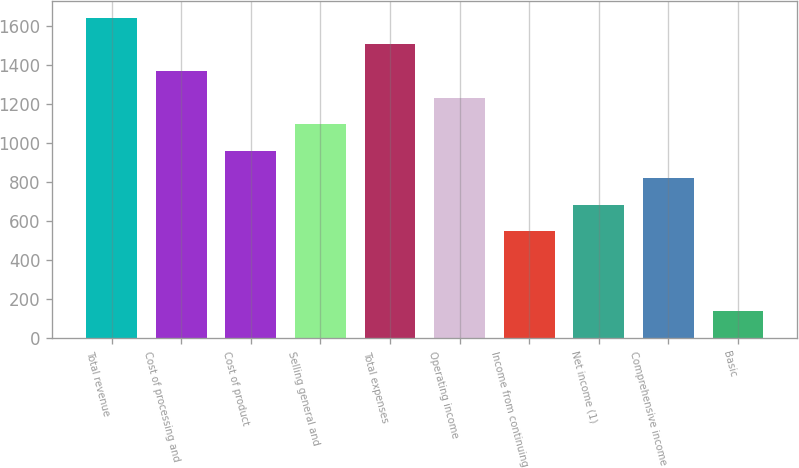Convert chart. <chart><loc_0><loc_0><loc_500><loc_500><bar_chart><fcel>Total revenue<fcel>Cost of processing and<fcel>Cost of product<fcel>Selling general and<fcel>Total expenses<fcel>Operating income<fcel>Income from continuing<fcel>Net income (1)<fcel>Comprehensive income<fcel>Basic<nl><fcel>1641.45<fcel>1368.01<fcel>957.85<fcel>1094.57<fcel>1504.73<fcel>1231.29<fcel>547.69<fcel>684.41<fcel>821.13<fcel>137.53<nl></chart> 